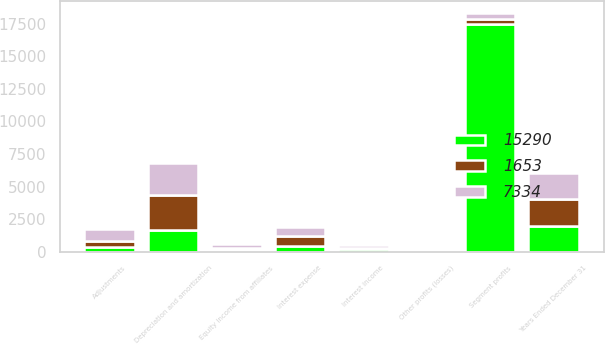Convert chart to OTSL. <chart><loc_0><loc_0><loc_500><loc_500><stacked_bar_chart><ecel><fcel>Years Ended December 31<fcel>Segment profits<fcel>Other profits (losses)<fcel>Adjustments<fcel>Interest income<fcel>Interest expense<fcel>Equity income from affiliates<fcel>Depreciation and amortization<nl><fcel>7334<fcel>2011<fcel>430.5<fcel>90<fcel>940<fcel>199<fcel>749<fcel>234<fcel>2436<nl><fcel>1653<fcel>2010<fcel>430.5<fcel>90<fcel>401<fcel>83<fcel>715<fcel>175<fcel>2671<nl><fcel>15290<fcel>2009<fcel>17450<fcel>137<fcel>399<fcel>210<fcel>460<fcel>153<fcel>1696<nl></chart> 